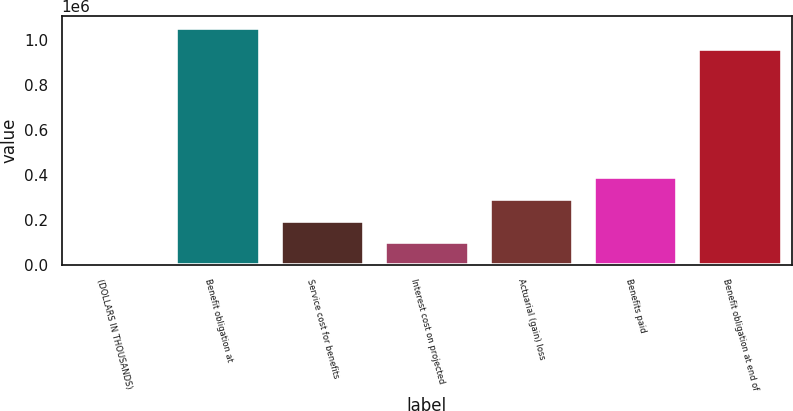Convert chart to OTSL. <chart><loc_0><loc_0><loc_500><loc_500><bar_chart><fcel>(DOLLARS IN THOUSANDS)<fcel>Benefit obligation at<fcel>Service cost for benefits<fcel>Interest cost on projected<fcel>Actuarial (gain) loss<fcel>Benefits paid<fcel>Benefit obligation at end of<nl><fcel>2018<fcel>1.05504e+06<fcel>196227<fcel>99122.3<fcel>293331<fcel>390435<fcel>957935<nl></chart> 